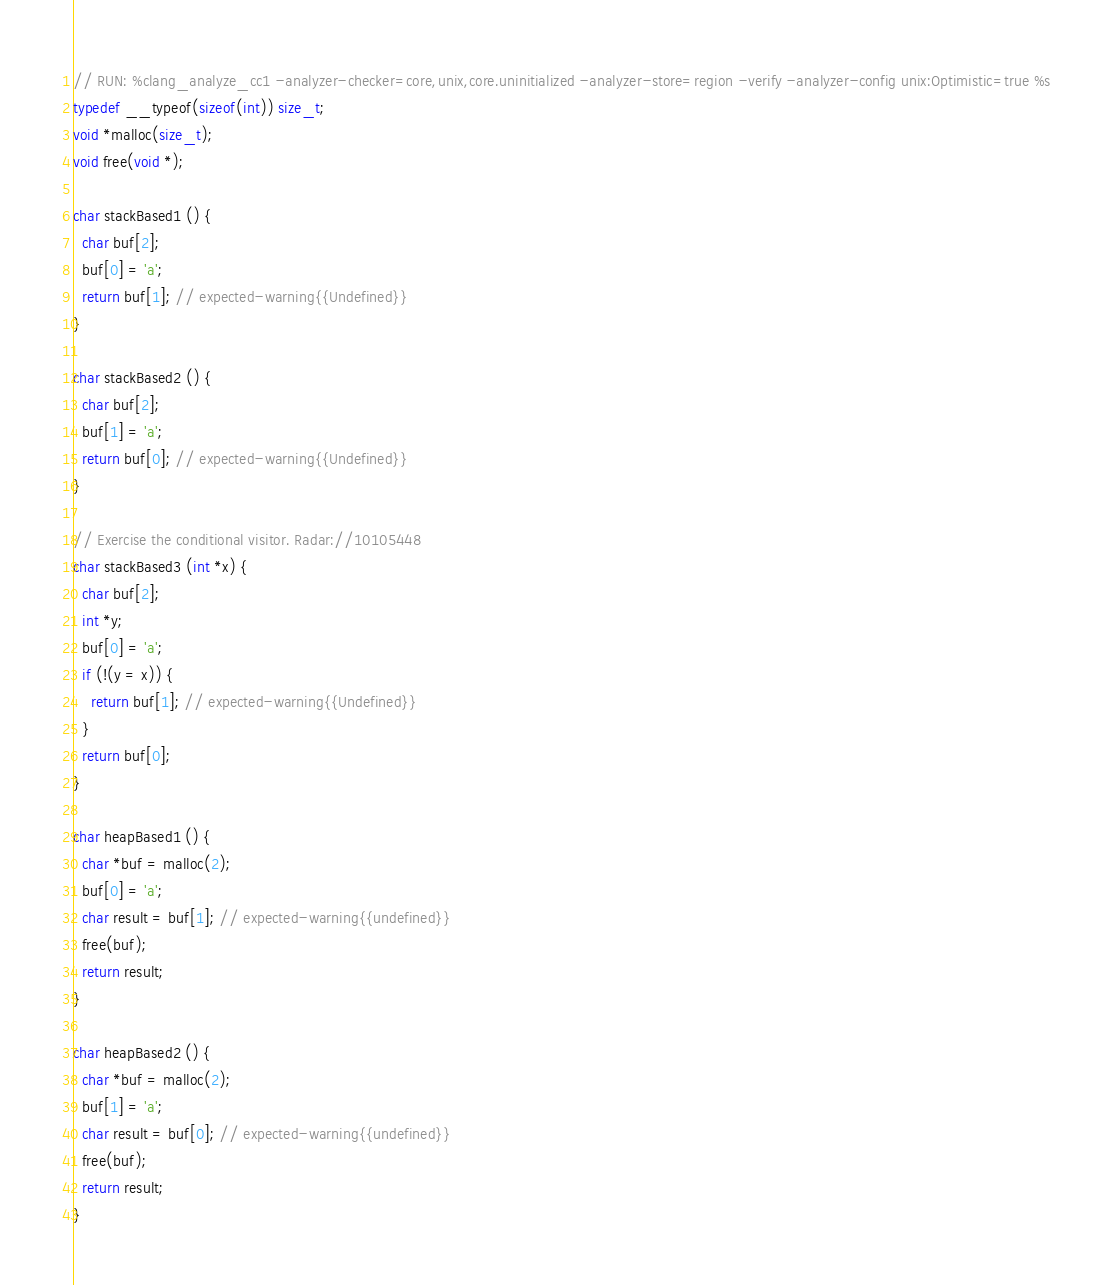<code> <loc_0><loc_0><loc_500><loc_500><_C_>// RUN: %clang_analyze_cc1 -analyzer-checker=core,unix,core.uninitialized -analyzer-store=region -verify -analyzer-config unix:Optimistic=true %s
typedef __typeof(sizeof(int)) size_t;
void *malloc(size_t);
void free(void *);

char stackBased1 () {
  char buf[2];
  buf[0] = 'a';
  return buf[1]; // expected-warning{{Undefined}}
}

char stackBased2 () {
  char buf[2];
  buf[1] = 'a';
  return buf[0]; // expected-warning{{Undefined}}
}

// Exercise the conditional visitor. Radar://10105448
char stackBased3 (int *x) {
  char buf[2];
  int *y;
  buf[0] = 'a';
  if (!(y = x)) {
    return buf[1]; // expected-warning{{Undefined}}
  }
  return buf[0];
}

char heapBased1 () {
  char *buf = malloc(2);
  buf[0] = 'a';
  char result = buf[1]; // expected-warning{{undefined}}
  free(buf);
  return result;
}

char heapBased2 () {
  char *buf = malloc(2);
  buf[1] = 'a';
  char result = buf[0]; // expected-warning{{undefined}}
  free(buf);
  return result;
}
</code> 